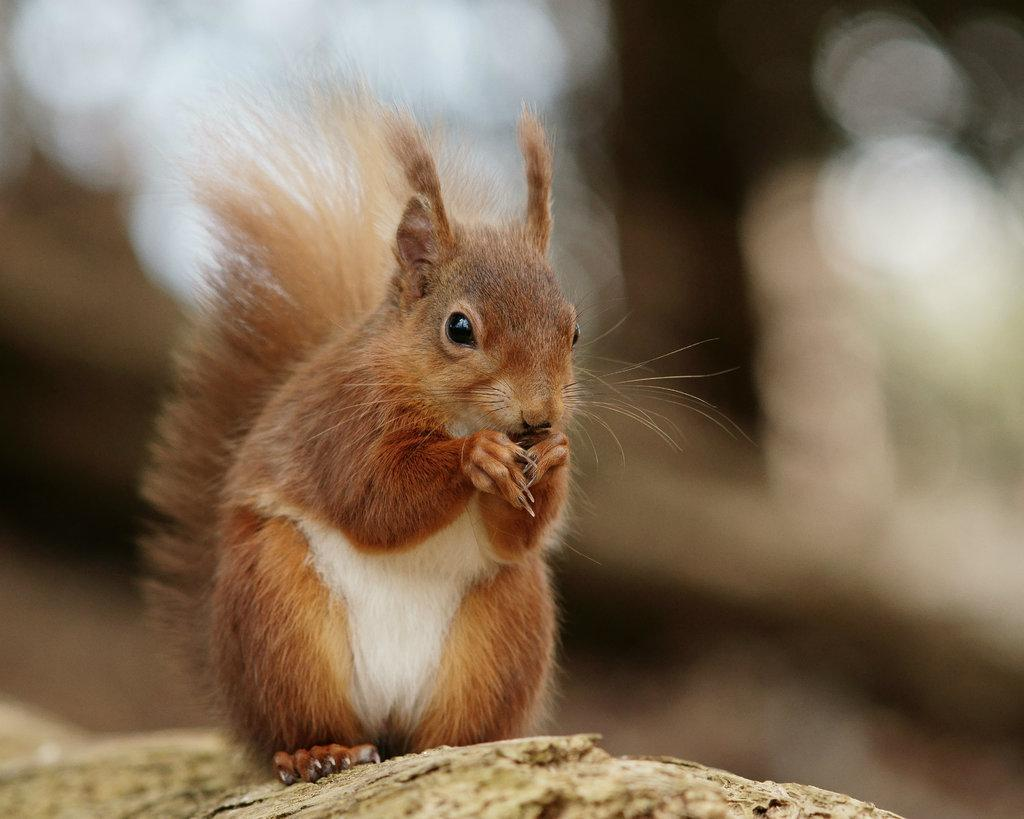What type of animal is in the image? There is a squirrel in the image. Can you describe the background of the image? The background of the image is blurry. What type of knee injury can be seen on the squirrel in the image? There is no knee injury visible on the squirrel in the image, as it is a healthy squirrel. What type of boundary is present in the image? There is no boundary present in the image; it features a squirrel and a blurry background. 